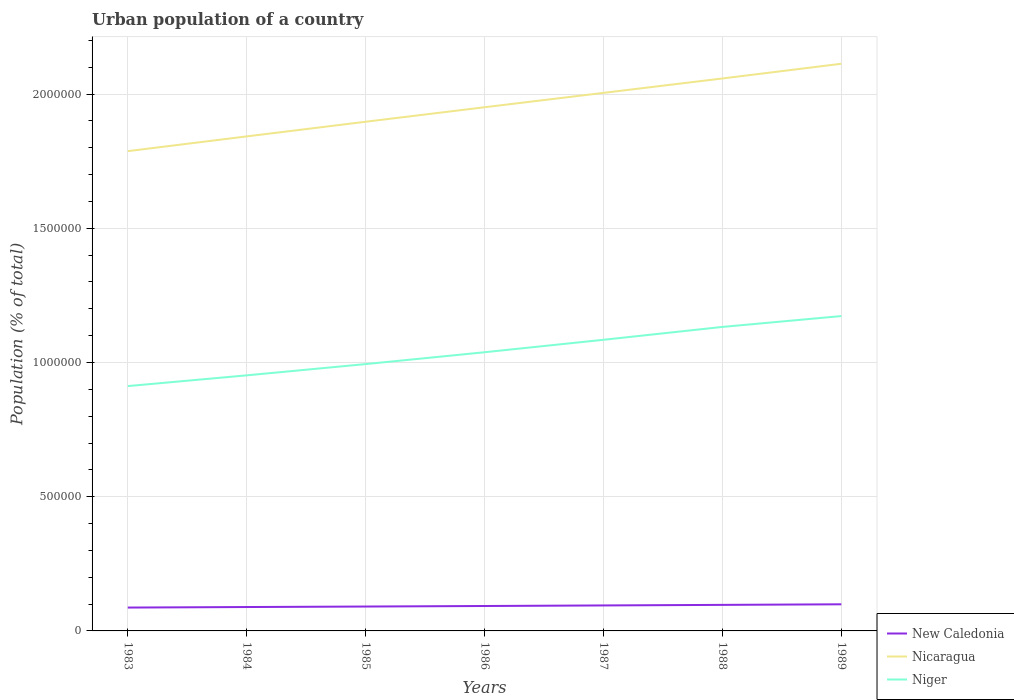Is the number of lines equal to the number of legend labels?
Make the answer very short. Yes. Across all years, what is the maximum urban population in New Caledonia?
Offer a terse response. 8.70e+04. In which year was the urban population in Niger maximum?
Your answer should be compact. 1983. What is the total urban population in New Caledonia in the graph?
Make the answer very short. -1.21e+04. What is the difference between the highest and the second highest urban population in New Caledonia?
Your answer should be very brief. 1.21e+04. What is the difference between the highest and the lowest urban population in Nicaragua?
Offer a terse response. 4. How many lines are there?
Ensure brevity in your answer.  3. Are the values on the major ticks of Y-axis written in scientific E-notation?
Provide a succinct answer. No. Does the graph contain any zero values?
Offer a very short reply. No. How are the legend labels stacked?
Your answer should be very brief. Vertical. What is the title of the graph?
Your response must be concise. Urban population of a country. Does "Bolivia" appear as one of the legend labels in the graph?
Keep it short and to the point. No. What is the label or title of the X-axis?
Offer a very short reply. Years. What is the label or title of the Y-axis?
Your answer should be compact. Population (% of total). What is the Population (% of total) of New Caledonia in 1983?
Your answer should be very brief. 8.70e+04. What is the Population (% of total) in Nicaragua in 1983?
Offer a very short reply. 1.79e+06. What is the Population (% of total) of Niger in 1983?
Provide a succinct answer. 9.12e+05. What is the Population (% of total) of New Caledonia in 1984?
Give a very brief answer. 8.90e+04. What is the Population (% of total) of Nicaragua in 1984?
Your answer should be very brief. 1.84e+06. What is the Population (% of total) of Niger in 1984?
Offer a terse response. 9.52e+05. What is the Population (% of total) of New Caledonia in 1985?
Your response must be concise. 9.09e+04. What is the Population (% of total) in Nicaragua in 1985?
Provide a succinct answer. 1.90e+06. What is the Population (% of total) of Niger in 1985?
Your answer should be compact. 9.94e+05. What is the Population (% of total) in New Caledonia in 1986?
Provide a short and direct response. 9.28e+04. What is the Population (% of total) of Nicaragua in 1986?
Your answer should be compact. 1.95e+06. What is the Population (% of total) of Niger in 1986?
Keep it short and to the point. 1.04e+06. What is the Population (% of total) of New Caledonia in 1987?
Keep it short and to the point. 9.49e+04. What is the Population (% of total) of Nicaragua in 1987?
Offer a very short reply. 2.00e+06. What is the Population (% of total) of Niger in 1987?
Keep it short and to the point. 1.08e+06. What is the Population (% of total) of New Caledonia in 1988?
Offer a terse response. 9.70e+04. What is the Population (% of total) of Nicaragua in 1988?
Your response must be concise. 2.06e+06. What is the Population (% of total) in Niger in 1988?
Ensure brevity in your answer.  1.13e+06. What is the Population (% of total) in New Caledonia in 1989?
Offer a very short reply. 9.92e+04. What is the Population (% of total) in Nicaragua in 1989?
Your answer should be very brief. 2.11e+06. What is the Population (% of total) in Niger in 1989?
Keep it short and to the point. 1.17e+06. Across all years, what is the maximum Population (% of total) of New Caledonia?
Offer a terse response. 9.92e+04. Across all years, what is the maximum Population (% of total) in Nicaragua?
Ensure brevity in your answer.  2.11e+06. Across all years, what is the maximum Population (% of total) of Niger?
Your response must be concise. 1.17e+06. Across all years, what is the minimum Population (% of total) of New Caledonia?
Ensure brevity in your answer.  8.70e+04. Across all years, what is the minimum Population (% of total) of Nicaragua?
Make the answer very short. 1.79e+06. Across all years, what is the minimum Population (% of total) in Niger?
Offer a terse response. 9.12e+05. What is the total Population (% of total) of New Caledonia in the graph?
Ensure brevity in your answer.  6.51e+05. What is the total Population (% of total) in Nicaragua in the graph?
Offer a terse response. 1.37e+07. What is the total Population (% of total) in Niger in the graph?
Offer a very short reply. 7.29e+06. What is the difference between the Population (% of total) of New Caledonia in 1983 and that in 1984?
Offer a terse response. -1956. What is the difference between the Population (% of total) in Nicaragua in 1983 and that in 1984?
Your response must be concise. -5.49e+04. What is the difference between the Population (% of total) of Niger in 1983 and that in 1984?
Offer a very short reply. -4.00e+04. What is the difference between the Population (% of total) in New Caledonia in 1983 and that in 1985?
Provide a short and direct response. -3832. What is the difference between the Population (% of total) in Nicaragua in 1983 and that in 1985?
Offer a terse response. -1.10e+05. What is the difference between the Population (% of total) of Niger in 1983 and that in 1985?
Offer a terse response. -8.20e+04. What is the difference between the Population (% of total) in New Caledonia in 1983 and that in 1986?
Offer a terse response. -5776. What is the difference between the Population (% of total) of Nicaragua in 1983 and that in 1986?
Offer a terse response. -1.64e+05. What is the difference between the Population (% of total) in Niger in 1983 and that in 1986?
Make the answer very short. -1.26e+05. What is the difference between the Population (% of total) of New Caledonia in 1983 and that in 1987?
Your answer should be very brief. -7875. What is the difference between the Population (% of total) in Nicaragua in 1983 and that in 1987?
Provide a short and direct response. -2.17e+05. What is the difference between the Population (% of total) in Niger in 1983 and that in 1987?
Provide a short and direct response. -1.72e+05. What is the difference between the Population (% of total) of New Caledonia in 1983 and that in 1988?
Provide a succinct answer. -9985. What is the difference between the Population (% of total) in Nicaragua in 1983 and that in 1988?
Ensure brevity in your answer.  -2.71e+05. What is the difference between the Population (% of total) of Niger in 1983 and that in 1988?
Your response must be concise. -2.20e+05. What is the difference between the Population (% of total) of New Caledonia in 1983 and that in 1989?
Keep it short and to the point. -1.21e+04. What is the difference between the Population (% of total) in Nicaragua in 1983 and that in 1989?
Provide a short and direct response. -3.26e+05. What is the difference between the Population (% of total) in Niger in 1983 and that in 1989?
Keep it short and to the point. -2.61e+05. What is the difference between the Population (% of total) of New Caledonia in 1984 and that in 1985?
Ensure brevity in your answer.  -1876. What is the difference between the Population (% of total) in Nicaragua in 1984 and that in 1985?
Offer a very short reply. -5.46e+04. What is the difference between the Population (% of total) in Niger in 1984 and that in 1985?
Keep it short and to the point. -4.19e+04. What is the difference between the Population (% of total) in New Caledonia in 1984 and that in 1986?
Offer a very short reply. -3820. What is the difference between the Population (% of total) in Nicaragua in 1984 and that in 1986?
Keep it short and to the point. -1.09e+05. What is the difference between the Population (% of total) of Niger in 1984 and that in 1986?
Your answer should be compact. -8.60e+04. What is the difference between the Population (% of total) of New Caledonia in 1984 and that in 1987?
Your response must be concise. -5919. What is the difference between the Population (% of total) in Nicaragua in 1984 and that in 1987?
Keep it short and to the point. -1.62e+05. What is the difference between the Population (% of total) of Niger in 1984 and that in 1987?
Your answer should be very brief. -1.32e+05. What is the difference between the Population (% of total) of New Caledonia in 1984 and that in 1988?
Offer a terse response. -8029. What is the difference between the Population (% of total) in Nicaragua in 1984 and that in 1988?
Your answer should be compact. -2.16e+05. What is the difference between the Population (% of total) of Niger in 1984 and that in 1988?
Ensure brevity in your answer.  -1.80e+05. What is the difference between the Population (% of total) of New Caledonia in 1984 and that in 1989?
Give a very brief answer. -1.02e+04. What is the difference between the Population (% of total) of Nicaragua in 1984 and that in 1989?
Your answer should be compact. -2.71e+05. What is the difference between the Population (% of total) of Niger in 1984 and that in 1989?
Make the answer very short. -2.21e+05. What is the difference between the Population (% of total) in New Caledonia in 1985 and that in 1986?
Your answer should be very brief. -1944. What is the difference between the Population (% of total) of Nicaragua in 1985 and that in 1986?
Your response must be concise. -5.40e+04. What is the difference between the Population (% of total) of Niger in 1985 and that in 1986?
Your answer should be compact. -4.41e+04. What is the difference between the Population (% of total) of New Caledonia in 1985 and that in 1987?
Offer a very short reply. -4043. What is the difference between the Population (% of total) of Nicaragua in 1985 and that in 1987?
Give a very brief answer. -1.08e+05. What is the difference between the Population (% of total) in Niger in 1985 and that in 1987?
Provide a short and direct response. -9.05e+04. What is the difference between the Population (% of total) in New Caledonia in 1985 and that in 1988?
Offer a terse response. -6153. What is the difference between the Population (% of total) of Nicaragua in 1985 and that in 1988?
Your answer should be very brief. -1.61e+05. What is the difference between the Population (% of total) of Niger in 1985 and that in 1988?
Your answer should be very brief. -1.38e+05. What is the difference between the Population (% of total) in New Caledonia in 1985 and that in 1989?
Give a very brief answer. -8313. What is the difference between the Population (% of total) of Nicaragua in 1985 and that in 1989?
Your response must be concise. -2.16e+05. What is the difference between the Population (% of total) in Niger in 1985 and that in 1989?
Provide a short and direct response. -1.79e+05. What is the difference between the Population (% of total) of New Caledonia in 1986 and that in 1987?
Your answer should be compact. -2099. What is the difference between the Population (% of total) in Nicaragua in 1986 and that in 1987?
Keep it short and to the point. -5.35e+04. What is the difference between the Population (% of total) in Niger in 1986 and that in 1987?
Your response must be concise. -4.64e+04. What is the difference between the Population (% of total) of New Caledonia in 1986 and that in 1988?
Provide a succinct answer. -4209. What is the difference between the Population (% of total) in Nicaragua in 1986 and that in 1988?
Keep it short and to the point. -1.07e+05. What is the difference between the Population (% of total) in Niger in 1986 and that in 1988?
Offer a terse response. -9.43e+04. What is the difference between the Population (% of total) of New Caledonia in 1986 and that in 1989?
Your response must be concise. -6369. What is the difference between the Population (% of total) of Nicaragua in 1986 and that in 1989?
Offer a very short reply. -1.62e+05. What is the difference between the Population (% of total) of Niger in 1986 and that in 1989?
Give a very brief answer. -1.35e+05. What is the difference between the Population (% of total) in New Caledonia in 1987 and that in 1988?
Offer a terse response. -2110. What is the difference between the Population (% of total) in Nicaragua in 1987 and that in 1988?
Your response must be concise. -5.37e+04. What is the difference between the Population (% of total) in Niger in 1987 and that in 1988?
Provide a short and direct response. -4.79e+04. What is the difference between the Population (% of total) in New Caledonia in 1987 and that in 1989?
Offer a terse response. -4270. What is the difference between the Population (% of total) in Nicaragua in 1987 and that in 1989?
Ensure brevity in your answer.  -1.08e+05. What is the difference between the Population (% of total) in Niger in 1987 and that in 1989?
Provide a short and direct response. -8.83e+04. What is the difference between the Population (% of total) of New Caledonia in 1988 and that in 1989?
Make the answer very short. -2160. What is the difference between the Population (% of total) of Nicaragua in 1988 and that in 1989?
Your response must be concise. -5.48e+04. What is the difference between the Population (% of total) of Niger in 1988 and that in 1989?
Your answer should be compact. -4.04e+04. What is the difference between the Population (% of total) of New Caledonia in 1983 and the Population (% of total) of Nicaragua in 1984?
Ensure brevity in your answer.  -1.76e+06. What is the difference between the Population (% of total) of New Caledonia in 1983 and the Population (% of total) of Niger in 1984?
Your answer should be very brief. -8.65e+05. What is the difference between the Population (% of total) of Nicaragua in 1983 and the Population (% of total) of Niger in 1984?
Give a very brief answer. 8.35e+05. What is the difference between the Population (% of total) in New Caledonia in 1983 and the Population (% of total) in Nicaragua in 1985?
Offer a very short reply. -1.81e+06. What is the difference between the Population (% of total) in New Caledonia in 1983 and the Population (% of total) in Niger in 1985?
Your response must be concise. -9.07e+05. What is the difference between the Population (% of total) in Nicaragua in 1983 and the Population (% of total) in Niger in 1985?
Provide a succinct answer. 7.93e+05. What is the difference between the Population (% of total) in New Caledonia in 1983 and the Population (% of total) in Nicaragua in 1986?
Provide a short and direct response. -1.86e+06. What is the difference between the Population (% of total) in New Caledonia in 1983 and the Population (% of total) in Niger in 1986?
Offer a terse response. -9.51e+05. What is the difference between the Population (% of total) in Nicaragua in 1983 and the Population (% of total) in Niger in 1986?
Provide a succinct answer. 7.49e+05. What is the difference between the Population (% of total) of New Caledonia in 1983 and the Population (% of total) of Nicaragua in 1987?
Your response must be concise. -1.92e+06. What is the difference between the Population (% of total) in New Caledonia in 1983 and the Population (% of total) in Niger in 1987?
Provide a succinct answer. -9.97e+05. What is the difference between the Population (% of total) in Nicaragua in 1983 and the Population (% of total) in Niger in 1987?
Ensure brevity in your answer.  7.03e+05. What is the difference between the Population (% of total) in New Caledonia in 1983 and the Population (% of total) in Nicaragua in 1988?
Offer a terse response. -1.97e+06. What is the difference between the Population (% of total) in New Caledonia in 1983 and the Population (% of total) in Niger in 1988?
Your answer should be very brief. -1.05e+06. What is the difference between the Population (% of total) of Nicaragua in 1983 and the Population (% of total) of Niger in 1988?
Keep it short and to the point. 6.55e+05. What is the difference between the Population (% of total) of New Caledonia in 1983 and the Population (% of total) of Nicaragua in 1989?
Ensure brevity in your answer.  -2.03e+06. What is the difference between the Population (% of total) of New Caledonia in 1983 and the Population (% of total) of Niger in 1989?
Your answer should be compact. -1.09e+06. What is the difference between the Population (% of total) of Nicaragua in 1983 and the Population (% of total) of Niger in 1989?
Give a very brief answer. 6.14e+05. What is the difference between the Population (% of total) in New Caledonia in 1984 and the Population (% of total) in Nicaragua in 1985?
Your answer should be compact. -1.81e+06. What is the difference between the Population (% of total) in New Caledonia in 1984 and the Population (% of total) in Niger in 1985?
Offer a very short reply. -9.05e+05. What is the difference between the Population (% of total) of Nicaragua in 1984 and the Population (% of total) of Niger in 1985?
Give a very brief answer. 8.48e+05. What is the difference between the Population (% of total) of New Caledonia in 1984 and the Population (% of total) of Nicaragua in 1986?
Give a very brief answer. -1.86e+06. What is the difference between the Population (% of total) in New Caledonia in 1984 and the Population (% of total) in Niger in 1986?
Give a very brief answer. -9.49e+05. What is the difference between the Population (% of total) of Nicaragua in 1984 and the Population (% of total) of Niger in 1986?
Offer a very short reply. 8.04e+05. What is the difference between the Population (% of total) in New Caledonia in 1984 and the Population (% of total) in Nicaragua in 1987?
Offer a terse response. -1.92e+06. What is the difference between the Population (% of total) in New Caledonia in 1984 and the Population (% of total) in Niger in 1987?
Ensure brevity in your answer.  -9.96e+05. What is the difference between the Population (% of total) in Nicaragua in 1984 and the Population (% of total) in Niger in 1987?
Provide a succinct answer. 7.58e+05. What is the difference between the Population (% of total) in New Caledonia in 1984 and the Population (% of total) in Nicaragua in 1988?
Offer a terse response. -1.97e+06. What is the difference between the Population (% of total) in New Caledonia in 1984 and the Population (% of total) in Niger in 1988?
Offer a very short reply. -1.04e+06. What is the difference between the Population (% of total) of Nicaragua in 1984 and the Population (% of total) of Niger in 1988?
Provide a succinct answer. 7.10e+05. What is the difference between the Population (% of total) in New Caledonia in 1984 and the Population (% of total) in Nicaragua in 1989?
Offer a terse response. -2.02e+06. What is the difference between the Population (% of total) of New Caledonia in 1984 and the Population (% of total) of Niger in 1989?
Ensure brevity in your answer.  -1.08e+06. What is the difference between the Population (% of total) in Nicaragua in 1984 and the Population (% of total) in Niger in 1989?
Your answer should be compact. 6.69e+05. What is the difference between the Population (% of total) of New Caledonia in 1985 and the Population (% of total) of Nicaragua in 1986?
Keep it short and to the point. -1.86e+06. What is the difference between the Population (% of total) of New Caledonia in 1985 and the Population (% of total) of Niger in 1986?
Your answer should be compact. -9.47e+05. What is the difference between the Population (% of total) in Nicaragua in 1985 and the Population (% of total) in Niger in 1986?
Ensure brevity in your answer.  8.59e+05. What is the difference between the Population (% of total) in New Caledonia in 1985 and the Population (% of total) in Nicaragua in 1987?
Provide a succinct answer. -1.91e+06. What is the difference between the Population (% of total) in New Caledonia in 1985 and the Population (% of total) in Niger in 1987?
Your response must be concise. -9.94e+05. What is the difference between the Population (% of total) of Nicaragua in 1985 and the Population (% of total) of Niger in 1987?
Offer a terse response. 8.12e+05. What is the difference between the Population (% of total) of New Caledonia in 1985 and the Population (% of total) of Nicaragua in 1988?
Make the answer very short. -1.97e+06. What is the difference between the Population (% of total) of New Caledonia in 1985 and the Population (% of total) of Niger in 1988?
Make the answer very short. -1.04e+06. What is the difference between the Population (% of total) of Nicaragua in 1985 and the Population (% of total) of Niger in 1988?
Make the answer very short. 7.64e+05. What is the difference between the Population (% of total) of New Caledonia in 1985 and the Population (% of total) of Nicaragua in 1989?
Ensure brevity in your answer.  -2.02e+06. What is the difference between the Population (% of total) of New Caledonia in 1985 and the Population (% of total) of Niger in 1989?
Your answer should be compact. -1.08e+06. What is the difference between the Population (% of total) of Nicaragua in 1985 and the Population (% of total) of Niger in 1989?
Your answer should be compact. 7.24e+05. What is the difference between the Population (% of total) in New Caledonia in 1986 and the Population (% of total) in Nicaragua in 1987?
Provide a short and direct response. -1.91e+06. What is the difference between the Population (% of total) in New Caledonia in 1986 and the Population (% of total) in Niger in 1987?
Give a very brief answer. -9.92e+05. What is the difference between the Population (% of total) in Nicaragua in 1986 and the Population (% of total) in Niger in 1987?
Your answer should be compact. 8.66e+05. What is the difference between the Population (% of total) in New Caledonia in 1986 and the Population (% of total) in Nicaragua in 1988?
Provide a succinct answer. -1.97e+06. What is the difference between the Population (% of total) of New Caledonia in 1986 and the Population (% of total) of Niger in 1988?
Your answer should be compact. -1.04e+06. What is the difference between the Population (% of total) of Nicaragua in 1986 and the Population (% of total) of Niger in 1988?
Make the answer very short. 8.18e+05. What is the difference between the Population (% of total) in New Caledonia in 1986 and the Population (% of total) in Nicaragua in 1989?
Ensure brevity in your answer.  -2.02e+06. What is the difference between the Population (% of total) of New Caledonia in 1986 and the Population (% of total) of Niger in 1989?
Provide a short and direct response. -1.08e+06. What is the difference between the Population (% of total) in Nicaragua in 1986 and the Population (% of total) in Niger in 1989?
Make the answer very short. 7.78e+05. What is the difference between the Population (% of total) in New Caledonia in 1987 and the Population (% of total) in Nicaragua in 1988?
Your answer should be very brief. -1.96e+06. What is the difference between the Population (% of total) of New Caledonia in 1987 and the Population (% of total) of Niger in 1988?
Your answer should be very brief. -1.04e+06. What is the difference between the Population (% of total) of Nicaragua in 1987 and the Population (% of total) of Niger in 1988?
Ensure brevity in your answer.  8.72e+05. What is the difference between the Population (% of total) in New Caledonia in 1987 and the Population (% of total) in Nicaragua in 1989?
Ensure brevity in your answer.  -2.02e+06. What is the difference between the Population (% of total) of New Caledonia in 1987 and the Population (% of total) of Niger in 1989?
Offer a terse response. -1.08e+06. What is the difference between the Population (% of total) in Nicaragua in 1987 and the Population (% of total) in Niger in 1989?
Make the answer very short. 8.31e+05. What is the difference between the Population (% of total) of New Caledonia in 1988 and the Population (% of total) of Nicaragua in 1989?
Give a very brief answer. -2.02e+06. What is the difference between the Population (% of total) in New Caledonia in 1988 and the Population (% of total) in Niger in 1989?
Make the answer very short. -1.08e+06. What is the difference between the Population (% of total) in Nicaragua in 1988 and the Population (% of total) in Niger in 1989?
Keep it short and to the point. 8.85e+05. What is the average Population (% of total) in New Caledonia per year?
Ensure brevity in your answer.  9.30e+04. What is the average Population (% of total) of Nicaragua per year?
Your answer should be very brief. 1.95e+06. What is the average Population (% of total) in Niger per year?
Provide a short and direct response. 1.04e+06. In the year 1983, what is the difference between the Population (% of total) of New Caledonia and Population (% of total) of Nicaragua?
Keep it short and to the point. -1.70e+06. In the year 1983, what is the difference between the Population (% of total) in New Caledonia and Population (% of total) in Niger?
Keep it short and to the point. -8.25e+05. In the year 1983, what is the difference between the Population (% of total) of Nicaragua and Population (% of total) of Niger?
Give a very brief answer. 8.75e+05. In the year 1984, what is the difference between the Population (% of total) of New Caledonia and Population (% of total) of Nicaragua?
Provide a succinct answer. -1.75e+06. In the year 1984, what is the difference between the Population (% of total) of New Caledonia and Population (% of total) of Niger?
Provide a succinct answer. -8.63e+05. In the year 1984, what is the difference between the Population (% of total) of Nicaragua and Population (% of total) of Niger?
Your answer should be very brief. 8.90e+05. In the year 1985, what is the difference between the Population (% of total) in New Caledonia and Population (% of total) in Nicaragua?
Your response must be concise. -1.81e+06. In the year 1985, what is the difference between the Population (% of total) in New Caledonia and Population (% of total) in Niger?
Ensure brevity in your answer.  -9.03e+05. In the year 1985, what is the difference between the Population (% of total) of Nicaragua and Population (% of total) of Niger?
Make the answer very short. 9.03e+05. In the year 1986, what is the difference between the Population (% of total) of New Caledonia and Population (% of total) of Nicaragua?
Offer a very short reply. -1.86e+06. In the year 1986, what is the difference between the Population (% of total) in New Caledonia and Population (% of total) in Niger?
Your answer should be very brief. -9.45e+05. In the year 1986, what is the difference between the Population (% of total) of Nicaragua and Population (% of total) of Niger?
Your answer should be compact. 9.13e+05. In the year 1987, what is the difference between the Population (% of total) of New Caledonia and Population (% of total) of Nicaragua?
Ensure brevity in your answer.  -1.91e+06. In the year 1987, what is the difference between the Population (% of total) in New Caledonia and Population (% of total) in Niger?
Offer a terse response. -9.90e+05. In the year 1987, what is the difference between the Population (% of total) in Nicaragua and Population (% of total) in Niger?
Your answer should be very brief. 9.20e+05. In the year 1988, what is the difference between the Population (% of total) of New Caledonia and Population (% of total) of Nicaragua?
Ensure brevity in your answer.  -1.96e+06. In the year 1988, what is the difference between the Population (% of total) in New Caledonia and Population (% of total) in Niger?
Offer a very short reply. -1.04e+06. In the year 1988, what is the difference between the Population (% of total) in Nicaragua and Population (% of total) in Niger?
Your response must be concise. 9.26e+05. In the year 1989, what is the difference between the Population (% of total) of New Caledonia and Population (% of total) of Nicaragua?
Your answer should be compact. -2.01e+06. In the year 1989, what is the difference between the Population (% of total) of New Caledonia and Population (% of total) of Niger?
Provide a succinct answer. -1.07e+06. In the year 1989, what is the difference between the Population (% of total) in Nicaragua and Population (% of total) in Niger?
Make the answer very short. 9.40e+05. What is the ratio of the Population (% of total) in Nicaragua in 1983 to that in 1984?
Offer a very short reply. 0.97. What is the ratio of the Population (% of total) of Niger in 1983 to that in 1984?
Your answer should be compact. 0.96. What is the ratio of the Population (% of total) of New Caledonia in 1983 to that in 1985?
Ensure brevity in your answer.  0.96. What is the ratio of the Population (% of total) of Nicaragua in 1983 to that in 1985?
Your answer should be very brief. 0.94. What is the ratio of the Population (% of total) of Niger in 1983 to that in 1985?
Offer a very short reply. 0.92. What is the ratio of the Population (% of total) of New Caledonia in 1983 to that in 1986?
Provide a succinct answer. 0.94. What is the ratio of the Population (% of total) of Nicaragua in 1983 to that in 1986?
Make the answer very short. 0.92. What is the ratio of the Population (% of total) in Niger in 1983 to that in 1986?
Your response must be concise. 0.88. What is the ratio of the Population (% of total) in New Caledonia in 1983 to that in 1987?
Offer a terse response. 0.92. What is the ratio of the Population (% of total) in Nicaragua in 1983 to that in 1987?
Your answer should be very brief. 0.89. What is the ratio of the Population (% of total) of Niger in 1983 to that in 1987?
Your answer should be compact. 0.84. What is the ratio of the Population (% of total) of New Caledonia in 1983 to that in 1988?
Offer a terse response. 0.9. What is the ratio of the Population (% of total) in Nicaragua in 1983 to that in 1988?
Make the answer very short. 0.87. What is the ratio of the Population (% of total) in Niger in 1983 to that in 1988?
Make the answer very short. 0.81. What is the ratio of the Population (% of total) of New Caledonia in 1983 to that in 1989?
Your answer should be compact. 0.88. What is the ratio of the Population (% of total) in Nicaragua in 1983 to that in 1989?
Your response must be concise. 0.85. What is the ratio of the Population (% of total) of Niger in 1983 to that in 1989?
Ensure brevity in your answer.  0.78. What is the ratio of the Population (% of total) of New Caledonia in 1984 to that in 1985?
Ensure brevity in your answer.  0.98. What is the ratio of the Population (% of total) of Nicaragua in 1984 to that in 1985?
Provide a succinct answer. 0.97. What is the ratio of the Population (% of total) of Niger in 1984 to that in 1985?
Keep it short and to the point. 0.96. What is the ratio of the Population (% of total) of New Caledonia in 1984 to that in 1986?
Your response must be concise. 0.96. What is the ratio of the Population (% of total) in Nicaragua in 1984 to that in 1986?
Offer a terse response. 0.94. What is the ratio of the Population (% of total) in Niger in 1984 to that in 1986?
Make the answer very short. 0.92. What is the ratio of the Population (% of total) in New Caledonia in 1984 to that in 1987?
Provide a short and direct response. 0.94. What is the ratio of the Population (% of total) of Nicaragua in 1984 to that in 1987?
Your answer should be very brief. 0.92. What is the ratio of the Population (% of total) in Niger in 1984 to that in 1987?
Your answer should be compact. 0.88. What is the ratio of the Population (% of total) in New Caledonia in 1984 to that in 1988?
Provide a succinct answer. 0.92. What is the ratio of the Population (% of total) in Nicaragua in 1984 to that in 1988?
Keep it short and to the point. 0.9. What is the ratio of the Population (% of total) of Niger in 1984 to that in 1988?
Make the answer very short. 0.84. What is the ratio of the Population (% of total) of New Caledonia in 1984 to that in 1989?
Your response must be concise. 0.9. What is the ratio of the Population (% of total) of Nicaragua in 1984 to that in 1989?
Make the answer very short. 0.87. What is the ratio of the Population (% of total) in Niger in 1984 to that in 1989?
Your answer should be compact. 0.81. What is the ratio of the Population (% of total) in New Caledonia in 1985 to that in 1986?
Ensure brevity in your answer.  0.98. What is the ratio of the Population (% of total) of Nicaragua in 1985 to that in 1986?
Keep it short and to the point. 0.97. What is the ratio of the Population (% of total) of Niger in 1985 to that in 1986?
Make the answer very short. 0.96. What is the ratio of the Population (% of total) of New Caledonia in 1985 to that in 1987?
Make the answer very short. 0.96. What is the ratio of the Population (% of total) in Nicaragua in 1985 to that in 1987?
Provide a short and direct response. 0.95. What is the ratio of the Population (% of total) of Niger in 1985 to that in 1987?
Your answer should be very brief. 0.92. What is the ratio of the Population (% of total) of New Caledonia in 1985 to that in 1988?
Your answer should be compact. 0.94. What is the ratio of the Population (% of total) of Nicaragua in 1985 to that in 1988?
Give a very brief answer. 0.92. What is the ratio of the Population (% of total) of Niger in 1985 to that in 1988?
Your response must be concise. 0.88. What is the ratio of the Population (% of total) in New Caledonia in 1985 to that in 1989?
Provide a short and direct response. 0.92. What is the ratio of the Population (% of total) in Nicaragua in 1985 to that in 1989?
Your answer should be very brief. 0.9. What is the ratio of the Population (% of total) of Niger in 1985 to that in 1989?
Offer a terse response. 0.85. What is the ratio of the Population (% of total) of New Caledonia in 1986 to that in 1987?
Offer a very short reply. 0.98. What is the ratio of the Population (% of total) of Nicaragua in 1986 to that in 1987?
Provide a succinct answer. 0.97. What is the ratio of the Population (% of total) in Niger in 1986 to that in 1987?
Keep it short and to the point. 0.96. What is the ratio of the Population (% of total) of New Caledonia in 1986 to that in 1988?
Give a very brief answer. 0.96. What is the ratio of the Population (% of total) in Nicaragua in 1986 to that in 1988?
Provide a succinct answer. 0.95. What is the ratio of the Population (% of total) of New Caledonia in 1986 to that in 1989?
Provide a short and direct response. 0.94. What is the ratio of the Population (% of total) in Nicaragua in 1986 to that in 1989?
Keep it short and to the point. 0.92. What is the ratio of the Population (% of total) in Niger in 1986 to that in 1989?
Your response must be concise. 0.89. What is the ratio of the Population (% of total) in New Caledonia in 1987 to that in 1988?
Your answer should be compact. 0.98. What is the ratio of the Population (% of total) in Nicaragua in 1987 to that in 1988?
Keep it short and to the point. 0.97. What is the ratio of the Population (% of total) of Niger in 1987 to that in 1988?
Your answer should be compact. 0.96. What is the ratio of the Population (% of total) in New Caledonia in 1987 to that in 1989?
Keep it short and to the point. 0.96. What is the ratio of the Population (% of total) of Nicaragua in 1987 to that in 1989?
Your answer should be compact. 0.95. What is the ratio of the Population (% of total) in Niger in 1987 to that in 1989?
Offer a terse response. 0.92. What is the ratio of the Population (% of total) in New Caledonia in 1988 to that in 1989?
Offer a very short reply. 0.98. What is the ratio of the Population (% of total) in Nicaragua in 1988 to that in 1989?
Offer a very short reply. 0.97. What is the ratio of the Population (% of total) of Niger in 1988 to that in 1989?
Your response must be concise. 0.97. What is the difference between the highest and the second highest Population (% of total) in New Caledonia?
Your response must be concise. 2160. What is the difference between the highest and the second highest Population (% of total) in Nicaragua?
Ensure brevity in your answer.  5.48e+04. What is the difference between the highest and the second highest Population (% of total) of Niger?
Your answer should be very brief. 4.04e+04. What is the difference between the highest and the lowest Population (% of total) in New Caledonia?
Keep it short and to the point. 1.21e+04. What is the difference between the highest and the lowest Population (% of total) of Nicaragua?
Give a very brief answer. 3.26e+05. What is the difference between the highest and the lowest Population (% of total) of Niger?
Ensure brevity in your answer.  2.61e+05. 